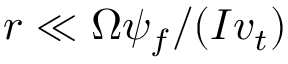<formula> <loc_0><loc_0><loc_500><loc_500>r \ll \Omega \psi _ { f } / ( I v _ { t } )</formula> 